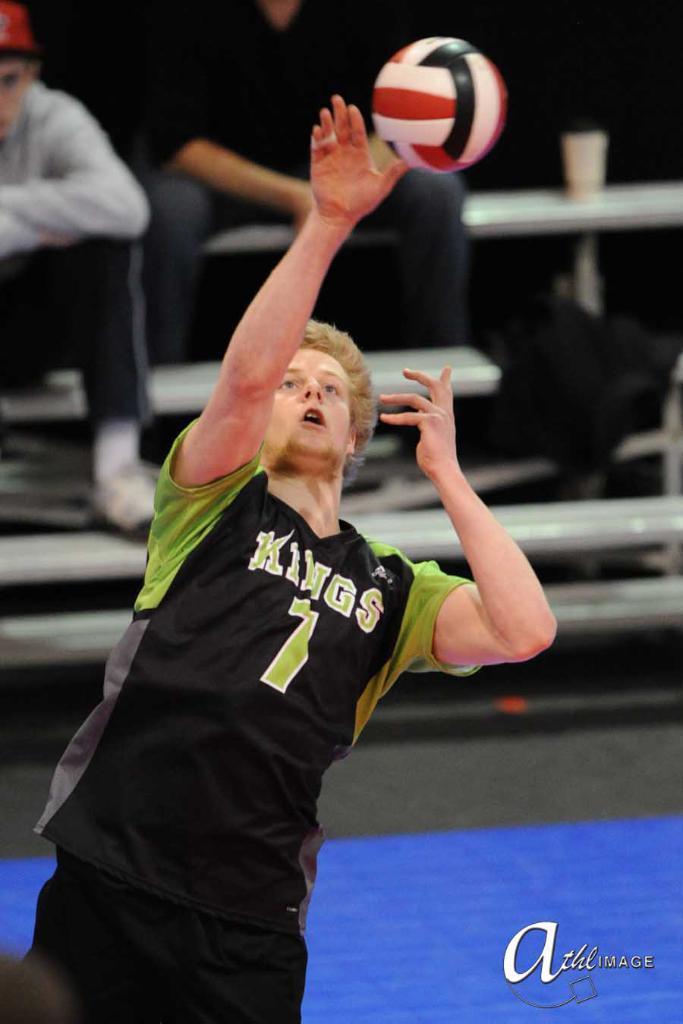Could you give a brief overview of what you see in this image? This picture shows a man playing volleyball and we see people seated and watching 